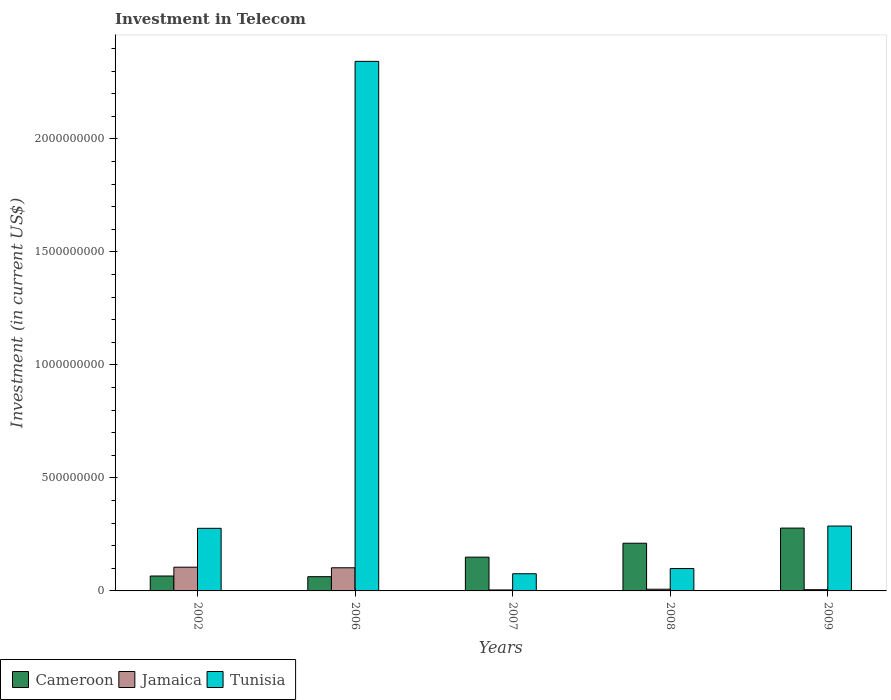Are the number of bars per tick equal to the number of legend labels?
Make the answer very short. Yes. Are the number of bars on each tick of the X-axis equal?
Your response must be concise. Yes. How many bars are there on the 4th tick from the left?
Keep it short and to the point. 3. What is the label of the 3rd group of bars from the left?
Provide a short and direct response. 2007. In how many cases, is the number of bars for a given year not equal to the number of legend labels?
Your answer should be very brief. 0. What is the amount invested in telecom in Cameroon in 2007?
Your answer should be very brief. 1.49e+08. Across all years, what is the maximum amount invested in telecom in Tunisia?
Offer a terse response. 2.34e+09. Across all years, what is the minimum amount invested in telecom in Jamaica?
Provide a succinct answer. 4.30e+06. What is the total amount invested in telecom in Jamaica in the graph?
Your answer should be very brief. 2.25e+08. What is the difference between the amount invested in telecom in Jamaica in 2002 and that in 2009?
Offer a very short reply. 9.96e+07. What is the difference between the amount invested in telecom in Cameroon in 2007 and the amount invested in telecom in Jamaica in 2006?
Give a very brief answer. 4.70e+07. What is the average amount invested in telecom in Cameroon per year?
Your answer should be very brief. 1.53e+08. In the year 2008, what is the difference between the amount invested in telecom in Cameroon and amount invested in telecom in Tunisia?
Provide a short and direct response. 1.12e+08. In how many years, is the amount invested in telecom in Tunisia greater than 1400000000 US$?
Provide a short and direct response. 1. What is the ratio of the amount invested in telecom in Cameroon in 2002 to that in 2007?
Offer a very short reply. 0.44. Is the amount invested in telecom in Tunisia in 2007 less than that in 2008?
Offer a terse response. Yes. What is the difference between the highest and the second highest amount invested in telecom in Cameroon?
Offer a terse response. 6.70e+07. What is the difference between the highest and the lowest amount invested in telecom in Cameroon?
Make the answer very short. 2.15e+08. What does the 2nd bar from the left in 2006 represents?
Make the answer very short. Jamaica. What does the 1st bar from the right in 2006 represents?
Keep it short and to the point. Tunisia. Is it the case that in every year, the sum of the amount invested in telecom in Cameroon and amount invested in telecom in Tunisia is greater than the amount invested in telecom in Jamaica?
Provide a succinct answer. Yes. How many bars are there?
Provide a short and direct response. 15. How many years are there in the graph?
Give a very brief answer. 5. What is the difference between two consecutive major ticks on the Y-axis?
Make the answer very short. 5.00e+08. Are the values on the major ticks of Y-axis written in scientific E-notation?
Offer a terse response. No. Does the graph contain grids?
Provide a short and direct response. No. How many legend labels are there?
Your response must be concise. 3. What is the title of the graph?
Your answer should be compact. Investment in Telecom. Does "Qatar" appear as one of the legend labels in the graph?
Make the answer very short. No. What is the label or title of the X-axis?
Your answer should be very brief. Years. What is the label or title of the Y-axis?
Ensure brevity in your answer.  Investment (in current US$). What is the Investment (in current US$) in Cameroon in 2002?
Provide a succinct answer. 6.60e+07. What is the Investment (in current US$) in Jamaica in 2002?
Make the answer very short. 1.05e+08. What is the Investment (in current US$) in Tunisia in 2002?
Make the answer very short. 2.77e+08. What is the Investment (in current US$) in Cameroon in 2006?
Provide a short and direct response. 6.30e+07. What is the Investment (in current US$) of Jamaica in 2006?
Give a very brief answer. 1.02e+08. What is the Investment (in current US$) of Tunisia in 2006?
Provide a succinct answer. 2.34e+09. What is the Investment (in current US$) of Cameroon in 2007?
Provide a succinct answer. 1.49e+08. What is the Investment (in current US$) in Jamaica in 2007?
Your answer should be compact. 4.30e+06. What is the Investment (in current US$) in Tunisia in 2007?
Offer a very short reply. 7.60e+07. What is the Investment (in current US$) in Cameroon in 2008?
Provide a short and direct response. 2.11e+08. What is the Investment (in current US$) of Jamaica in 2008?
Provide a succinct answer. 7.50e+06. What is the Investment (in current US$) in Tunisia in 2008?
Your response must be concise. 9.90e+07. What is the Investment (in current US$) of Cameroon in 2009?
Give a very brief answer. 2.78e+08. What is the Investment (in current US$) in Jamaica in 2009?
Your response must be concise. 5.40e+06. What is the Investment (in current US$) in Tunisia in 2009?
Give a very brief answer. 2.87e+08. Across all years, what is the maximum Investment (in current US$) in Cameroon?
Offer a very short reply. 2.78e+08. Across all years, what is the maximum Investment (in current US$) of Jamaica?
Give a very brief answer. 1.05e+08. Across all years, what is the maximum Investment (in current US$) in Tunisia?
Your answer should be very brief. 2.34e+09. Across all years, what is the minimum Investment (in current US$) of Cameroon?
Keep it short and to the point. 6.30e+07. Across all years, what is the minimum Investment (in current US$) of Jamaica?
Offer a terse response. 4.30e+06. Across all years, what is the minimum Investment (in current US$) in Tunisia?
Ensure brevity in your answer.  7.60e+07. What is the total Investment (in current US$) in Cameroon in the graph?
Make the answer very short. 7.67e+08. What is the total Investment (in current US$) of Jamaica in the graph?
Make the answer very short. 2.25e+08. What is the total Investment (in current US$) in Tunisia in the graph?
Offer a very short reply. 3.08e+09. What is the difference between the Investment (in current US$) in Jamaica in 2002 and that in 2006?
Your response must be concise. 2.60e+06. What is the difference between the Investment (in current US$) of Tunisia in 2002 and that in 2006?
Make the answer very short. -2.07e+09. What is the difference between the Investment (in current US$) of Cameroon in 2002 and that in 2007?
Your answer should be very brief. -8.34e+07. What is the difference between the Investment (in current US$) of Jamaica in 2002 and that in 2007?
Keep it short and to the point. 1.01e+08. What is the difference between the Investment (in current US$) in Tunisia in 2002 and that in 2007?
Your answer should be compact. 2.01e+08. What is the difference between the Investment (in current US$) of Cameroon in 2002 and that in 2008?
Keep it short and to the point. -1.45e+08. What is the difference between the Investment (in current US$) in Jamaica in 2002 and that in 2008?
Offer a very short reply. 9.75e+07. What is the difference between the Investment (in current US$) in Tunisia in 2002 and that in 2008?
Keep it short and to the point. 1.78e+08. What is the difference between the Investment (in current US$) in Cameroon in 2002 and that in 2009?
Give a very brief answer. -2.12e+08. What is the difference between the Investment (in current US$) of Jamaica in 2002 and that in 2009?
Ensure brevity in your answer.  9.96e+07. What is the difference between the Investment (in current US$) in Tunisia in 2002 and that in 2009?
Your answer should be compact. -1.00e+07. What is the difference between the Investment (in current US$) in Cameroon in 2006 and that in 2007?
Ensure brevity in your answer.  -8.64e+07. What is the difference between the Investment (in current US$) of Jamaica in 2006 and that in 2007?
Make the answer very short. 9.81e+07. What is the difference between the Investment (in current US$) in Tunisia in 2006 and that in 2007?
Give a very brief answer. 2.27e+09. What is the difference between the Investment (in current US$) in Cameroon in 2006 and that in 2008?
Make the answer very short. -1.48e+08. What is the difference between the Investment (in current US$) of Jamaica in 2006 and that in 2008?
Your response must be concise. 9.49e+07. What is the difference between the Investment (in current US$) in Tunisia in 2006 and that in 2008?
Give a very brief answer. 2.24e+09. What is the difference between the Investment (in current US$) in Cameroon in 2006 and that in 2009?
Provide a short and direct response. -2.15e+08. What is the difference between the Investment (in current US$) in Jamaica in 2006 and that in 2009?
Provide a short and direct response. 9.70e+07. What is the difference between the Investment (in current US$) of Tunisia in 2006 and that in 2009?
Keep it short and to the point. 2.06e+09. What is the difference between the Investment (in current US$) of Cameroon in 2007 and that in 2008?
Your answer should be very brief. -6.16e+07. What is the difference between the Investment (in current US$) in Jamaica in 2007 and that in 2008?
Your response must be concise. -3.20e+06. What is the difference between the Investment (in current US$) of Tunisia in 2007 and that in 2008?
Your answer should be compact. -2.30e+07. What is the difference between the Investment (in current US$) in Cameroon in 2007 and that in 2009?
Your answer should be compact. -1.29e+08. What is the difference between the Investment (in current US$) of Jamaica in 2007 and that in 2009?
Your answer should be compact. -1.10e+06. What is the difference between the Investment (in current US$) in Tunisia in 2007 and that in 2009?
Your answer should be very brief. -2.11e+08. What is the difference between the Investment (in current US$) of Cameroon in 2008 and that in 2009?
Provide a succinct answer. -6.70e+07. What is the difference between the Investment (in current US$) of Jamaica in 2008 and that in 2009?
Give a very brief answer. 2.10e+06. What is the difference between the Investment (in current US$) in Tunisia in 2008 and that in 2009?
Give a very brief answer. -1.88e+08. What is the difference between the Investment (in current US$) of Cameroon in 2002 and the Investment (in current US$) of Jamaica in 2006?
Offer a very short reply. -3.64e+07. What is the difference between the Investment (in current US$) of Cameroon in 2002 and the Investment (in current US$) of Tunisia in 2006?
Make the answer very short. -2.28e+09. What is the difference between the Investment (in current US$) in Jamaica in 2002 and the Investment (in current US$) in Tunisia in 2006?
Your answer should be very brief. -2.24e+09. What is the difference between the Investment (in current US$) in Cameroon in 2002 and the Investment (in current US$) in Jamaica in 2007?
Provide a short and direct response. 6.17e+07. What is the difference between the Investment (in current US$) of Cameroon in 2002 and the Investment (in current US$) of Tunisia in 2007?
Ensure brevity in your answer.  -1.00e+07. What is the difference between the Investment (in current US$) of Jamaica in 2002 and the Investment (in current US$) of Tunisia in 2007?
Offer a terse response. 2.90e+07. What is the difference between the Investment (in current US$) in Cameroon in 2002 and the Investment (in current US$) in Jamaica in 2008?
Your answer should be very brief. 5.85e+07. What is the difference between the Investment (in current US$) in Cameroon in 2002 and the Investment (in current US$) in Tunisia in 2008?
Give a very brief answer. -3.30e+07. What is the difference between the Investment (in current US$) in Cameroon in 2002 and the Investment (in current US$) in Jamaica in 2009?
Provide a succinct answer. 6.06e+07. What is the difference between the Investment (in current US$) of Cameroon in 2002 and the Investment (in current US$) of Tunisia in 2009?
Your answer should be very brief. -2.21e+08. What is the difference between the Investment (in current US$) in Jamaica in 2002 and the Investment (in current US$) in Tunisia in 2009?
Your answer should be very brief. -1.82e+08. What is the difference between the Investment (in current US$) in Cameroon in 2006 and the Investment (in current US$) in Jamaica in 2007?
Give a very brief answer. 5.87e+07. What is the difference between the Investment (in current US$) in Cameroon in 2006 and the Investment (in current US$) in Tunisia in 2007?
Provide a short and direct response. -1.30e+07. What is the difference between the Investment (in current US$) in Jamaica in 2006 and the Investment (in current US$) in Tunisia in 2007?
Keep it short and to the point. 2.64e+07. What is the difference between the Investment (in current US$) of Cameroon in 2006 and the Investment (in current US$) of Jamaica in 2008?
Make the answer very short. 5.55e+07. What is the difference between the Investment (in current US$) of Cameroon in 2006 and the Investment (in current US$) of Tunisia in 2008?
Provide a succinct answer. -3.60e+07. What is the difference between the Investment (in current US$) of Jamaica in 2006 and the Investment (in current US$) of Tunisia in 2008?
Your answer should be compact. 3.40e+06. What is the difference between the Investment (in current US$) in Cameroon in 2006 and the Investment (in current US$) in Jamaica in 2009?
Your response must be concise. 5.76e+07. What is the difference between the Investment (in current US$) of Cameroon in 2006 and the Investment (in current US$) of Tunisia in 2009?
Give a very brief answer. -2.24e+08. What is the difference between the Investment (in current US$) in Jamaica in 2006 and the Investment (in current US$) in Tunisia in 2009?
Your answer should be very brief. -1.85e+08. What is the difference between the Investment (in current US$) in Cameroon in 2007 and the Investment (in current US$) in Jamaica in 2008?
Your answer should be very brief. 1.42e+08. What is the difference between the Investment (in current US$) of Cameroon in 2007 and the Investment (in current US$) of Tunisia in 2008?
Provide a short and direct response. 5.04e+07. What is the difference between the Investment (in current US$) of Jamaica in 2007 and the Investment (in current US$) of Tunisia in 2008?
Make the answer very short. -9.47e+07. What is the difference between the Investment (in current US$) of Cameroon in 2007 and the Investment (in current US$) of Jamaica in 2009?
Offer a terse response. 1.44e+08. What is the difference between the Investment (in current US$) in Cameroon in 2007 and the Investment (in current US$) in Tunisia in 2009?
Offer a terse response. -1.38e+08. What is the difference between the Investment (in current US$) of Jamaica in 2007 and the Investment (in current US$) of Tunisia in 2009?
Your response must be concise. -2.83e+08. What is the difference between the Investment (in current US$) of Cameroon in 2008 and the Investment (in current US$) of Jamaica in 2009?
Your response must be concise. 2.06e+08. What is the difference between the Investment (in current US$) in Cameroon in 2008 and the Investment (in current US$) in Tunisia in 2009?
Give a very brief answer. -7.60e+07. What is the difference between the Investment (in current US$) of Jamaica in 2008 and the Investment (in current US$) of Tunisia in 2009?
Your answer should be compact. -2.80e+08. What is the average Investment (in current US$) of Cameroon per year?
Your answer should be compact. 1.53e+08. What is the average Investment (in current US$) in Jamaica per year?
Ensure brevity in your answer.  4.49e+07. What is the average Investment (in current US$) in Tunisia per year?
Your answer should be compact. 6.16e+08. In the year 2002, what is the difference between the Investment (in current US$) of Cameroon and Investment (in current US$) of Jamaica?
Your answer should be very brief. -3.90e+07. In the year 2002, what is the difference between the Investment (in current US$) in Cameroon and Investment (in current US$) in Tunisia?
Offer a very short reply. -2.11e+08. In the year 2002, what is the difference between the Investment (in current US$) of Jamaica and Investment (in current US$) of Tunisia?
Your response must be concise. -1.72e+08. In the year 2006, what is the difference between the Investment (in current US$) of Cameroon and Investment (in current US$) of Jamaica?
Offer a terse response. -3.94e+07. In the year 2006, what is the difference between the Investment (in current US$) of Cameroon and Investment (in current US$) of Tunisia?
Your answer should be very brief. -2.28e+09. In the year 2006, what is the difference between the Investment (in current US$) of Jamaica and Investment (in current US$) of Tunisia?
Provide a succinct answer. -2.24e+09. In the year 2007, what is the difference between the Investment (in current US$) in Cameroon and Investment (in current US$) in Jamaica?
Provide a short and direct response. 1.45e+08. In the year 2007, what is the difference between the Investment (in current US$) of Cameroon and Investment (in current US$) of Tunisia?
Keep it short and to the point. 7.34e+07. In the year 2007, what is the difference between the Investment (in current US$) of Jamaica and Investment (in current US$) of Tunisia?
Your response must be concise. -7.17e+07. In the year 2008, what is the difference between the Investment (in current US$) in Cameroon and Investment (in current US$) in Jamaica?
Provide a short and direct response. 2.04e+08. In the year 2008, what is the difference between the Investment (in current US$) in Cameroon and Investment (in current US$) in Tunisia?
Ensure brevity in your answer.  1.12e+08. In the year 2008, what is the difference between the Investment (in current US$) in Jamaica and Investment (in current US$) in Tunisia?
Keep it short and to the point. -9.15e+07. In the year 2009, what is the difference between the Investment (in current US$) in Cameroon and Investment (in current US$) in Jamaica?
Provide a succinct answer. 2.73e+08. In the year 2009, what is the difference between the Investment (in current US$) in Cameroon and Investment (in current US$) in Tunisia?
Your answer should be compact. -9.00e+06. In the year 2009, what is the difference between the Investment (in current US$) of Jamaica and Investment (in current US$) of Tunisia?
Offer a terse response. -2.82e+08. What is the ratio of the Investment (in current US$) of Cameroon in 2002 to that in 2006?
Provide a succinct answer. 1.05. What is the ratio of the Investment (in current US$) of Jamaica in 2002 to that in 2006?
Give a very brief answer. 1.03. What is the ratio of the Investment (in current US$) of Tunisia in 2002 to that in 2006?
Offer a terse response. 0.12. What is the ratio of the Investment (in current US$) of Cameroon in 2002 to that in 2007?
Provide a succinct answer. 0.44. What is the ratio of the Investment (in current US$) of Jamaica in 2002 to that in 2007?
Offer a terse response. 24.42. What is the ratio of the Investment (in current US$) in Tunisia in 2002 to that in 2007?
Give a very brief answer. 3.64. What is the ratio of the Investment (in current US$) in Cameroon in 2002 to that in 2008?
Your answer should be very brief. 0.31. What is the ratio of the Investment (in current US$) of Tunisia in 2002 to that in 2008?
Ensure brevity in your answer.  2.8. What is the ratio of the Investment (in current US$) of Cameroon in 2002 to that in 2009?
Ensure brevity in your answer.  0.24. What is the ratio of the Investment (in current US$) in Jamaica in 2002 to that in 2009?
Your answer should be compact. 19.44. What is the ratio of the Investment (in current US$) of Tunisia in 2002 to that in 2009?
Your answer should be compact. 0.97. What is the ratio of the Investment (in current US$) of Cameroon in 2006 to that in 2007?
Offer a terse response. 0.42. What is the ratio of the Investment (in current US$) of Jamaica in 2006 to that in 2007?
Make the answer very short. 23.81. What is the ratio of the Investment (in current US$) of Tunisia in 2006 to that in 2007?
Offer a very short reply. 30.83. What is the ratio of the Investment (in current US$) in Cameroon in 2006 to that in 2008?
Offer a very short reply. 0.3. What is the ratio of the Investment (in current US$) of Jamaica in 2006 to that in 2008?
Keep it short and to the point. 13.65. What is the ratio of the Investment (in current US$) of Tunisia in 2006 to that in 2008?
Your response must be concise. 23.67. What is the ratio of the Investment (in current US$) of Cameroon in 2006 to that in 2009?
Offer a very short reply. 0.23. What is the ratio of the Investment (in current US$) of Jamaica in 2006 to that in 2009?
Give a very brief answer. 18.96. What is the ratio of the Investment (in current US$) in Tunisia in 2006 to that in 2009?
Your answer should be compact. 8.16. What is the ratio of the Investment (in current US$) of Cameroon in 2007 to that in 2008?
Make the answer very short. 0.71. What is the ratio of the Investment (in current US$) of Jamaica in 2007 to that in 2008?
Your response must be concise. 0.57. What is the ratio of the Investment (in current US$) of Tunisia in 2007 to that in 2008?
Your answer should be very brief. 0.77. What is the ratio of the Investment (in current US$) of Cameroon in 2007 to that in 2009?
Keep it short and to the point. 0.54. What is the ratio of the Investment (in current US$) of Jamaica in 2007 to that in 2009?
Provide a succinct answer. 0.8. What is the ratio of the Investment (in current US$) in Tunisia in 2007 to that in 2009?
Offer a terse response. 0.26. What is the ratio of the Investment (in current US$) in Cameroon in 2008 to that in 2009?
Your answer should be very brief. 0.76. What is the ratio of the Investment (in current US$) in Jamaica in 2008 to that in 2009?
Your answer should be compact. 1.39. What is the ratio of the Investment (in current US$) of Tunisia in 2008 to that in 2009?
Offer a very short reply. 0.34. What is the difference between the highest and the second highest Investment (in current US$) in Cameroon?
Ensure brevity in your answer.  6.70e+07. What is the difference between the highest and the second highest Investment (in current US$) in Jamaica?
Provide a succinct answer. 2.60e+06. What is the difference between the highest and the second highest Investment (in current US$) of Tunisia?
Your answer should be very brief. 2.06e+09. What is the difference between the highest and the lowest Investment (in current US$) of Cameroon?
Make the answer very short. 2.15e+08. What is the difference between the highest and the lowest Investment (in current US$) in Jamaica?
Your answer should be very brief. 1.01e+08. What is the difference between the highest and the lowest Investment (in current US$) of Tunisia?
Provide a succinct answer. 2.27e+09. 